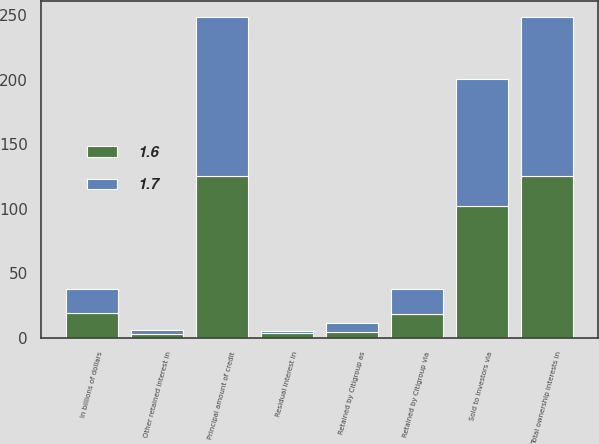Convert chart. <chart><loc_0><loc_0><loc_500><loc_500><stacked_bar_chart><ecel><fcel>In billions of dollars<fcel>Principal amount of credit<fcel>Sold to investors via<fcel>Retained by Citigroup as<fcel>Retained by Citigroup via<fcel>Total ownership interests in<fcel>Other retained interest in<fcel>Residual interest in<nl><fcel>1.7<fcel>18.75<fcel>123.9<fcel>98.2<fcel>6.5<fcel>19.2<fcel>123.9<fcel>3.1<fcel>1.7<nl><fcel>1.6<fcel>18.75<fcel>125.1<fcel>102.3<fcel>4.5<fcel>18.3<fcel>125.1<fcel>3<fcel>3.4<nl></chart> 